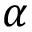<formula> <loc_0><loc_0><loc_500><loc_500>\alpha</formula> 